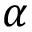<formula> <loc_0><loc_0><loc_500><loc_500>\alpha</formula> 